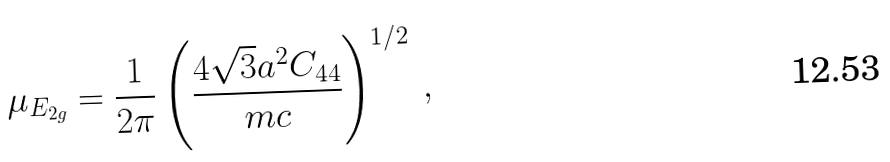<formula> <loc_0><loc_0><loc_500><loc_500>\mu _ { E _ { 2 g } } = \frac { 1 } { 2 \pi } \left ( \frac { 4 \sqrt { 3 } a ^ { 2 } C _ { 4 4 } } { m c } \right ) ^ { 1 / 2 } \, ,</formula> 